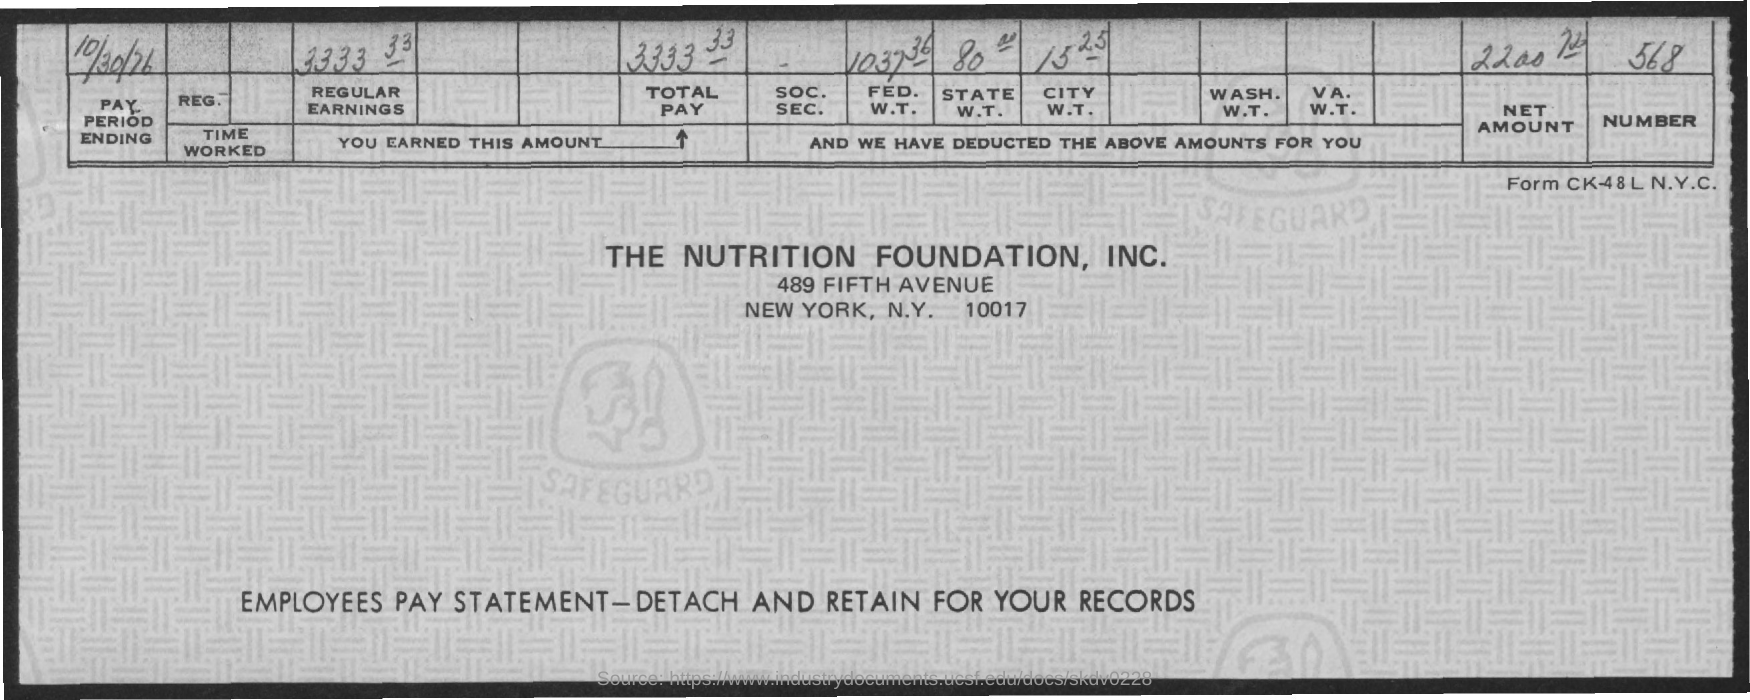When is the pay period ending?
Ensure brevity in your answer.  10/30/76. 